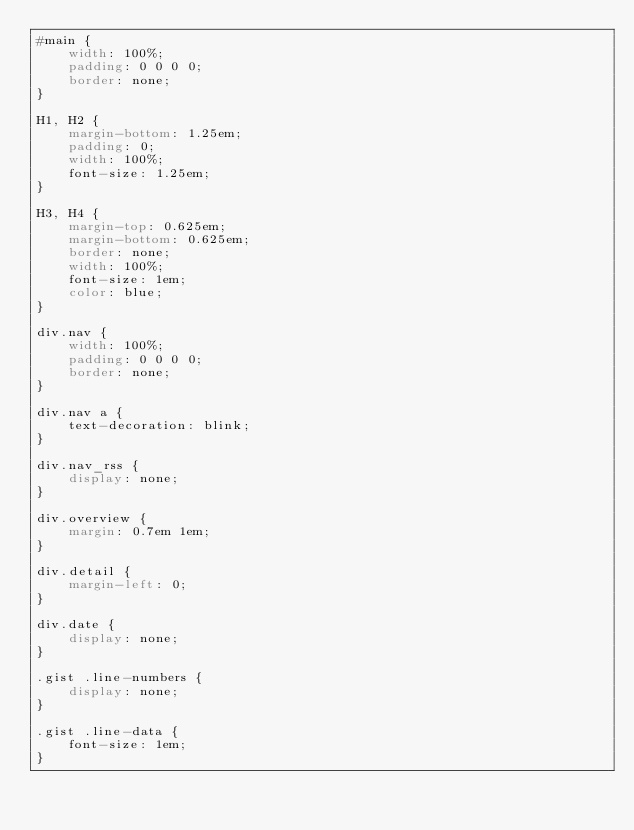Convert code to text. <code><loc_0><loc_0><loc_500><loc_500><_CSS_>#main {
    width: 100%;
    padding: 0 0 0 0;
    border: none;
}

H1, H2 {
    margin-bottom: 1.25em;
    padding: 0;
    width: 100%;
    font-size: 1.25em;
}

H3, H4 {
    margin-top: 0.625em;
    margin-bottom: 0.625em;
    border: none;
    width: 100%;
    font-size: 1em;
    color: blue;
}

div.nav {
    width: 100%;
    padding: 0 0 0 0;
    border: none;
}

div.nav a {
    text-decoration: blink;
}

div.nav_rss {
    display: none;
}

div.overview {
    margin: 0.7em 1em;
}

div.detail {
    margin-left: 0;
}

div.date {
    display: none;
}

.gist .line-numbers {
    display: none;
}

.gist .line-data {
    font-size: 1em;
}
</code> 